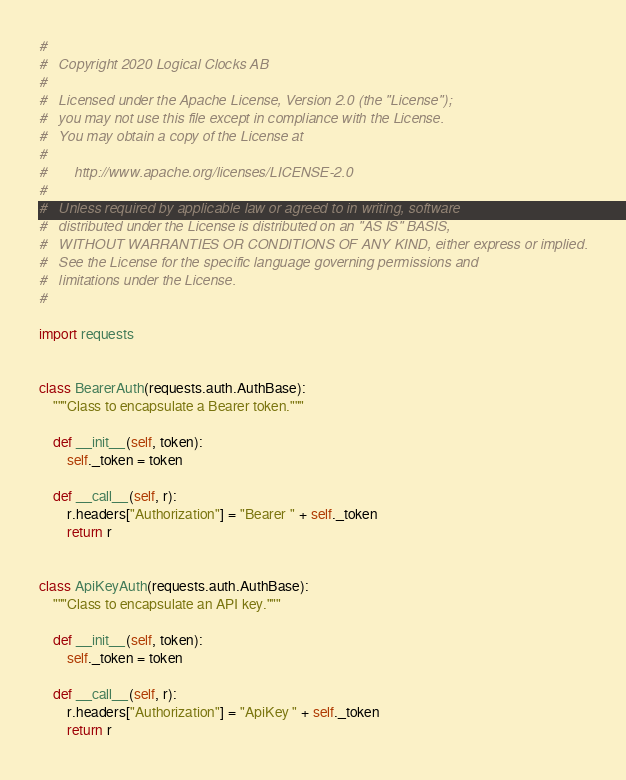<code> <loc_0><loc_0><loc_500><loc_500><_Python_>#
#   Copyright 2020 Logical Clocks AB
#
#   Licensed under the Apache License, Version 2.0 (the "License");
#   you may not use this file except in compliance with the License.
#   You may obtain a copy of the License at
#
#       http://www.apache.org/licenses/LICENSE-2.0
#
#   Unless required by applicable law or agreed to in writing, software
#   distributed under the License is distributed on an "AS IS" BASIS,
#   WITHOUT WARRANTIES OR CONDITIONS OF ANY KIND, either express or implied.
#   See the License for the specific language governing permissions and
#   limitations under the License.
#

import requests


class BearerAuth(requests.auth.AuthBase):
    """Class to encapsulate a Bearer token."""

    def __init__(self, token):
        self._token = token

    def __call__(self, r):
        r.headers["Authorization"] = "Bearer " + self._token
        return r


class ApiKeyAuth(requests.auth.AuthBase):
    """Class to encapsulate an API key."""

    def __init__(self, token):
        self._token = token

    def __call__(self, r):
        r.headers["Authorization"] = "ApiKey " + self._token
        return r
</code> 